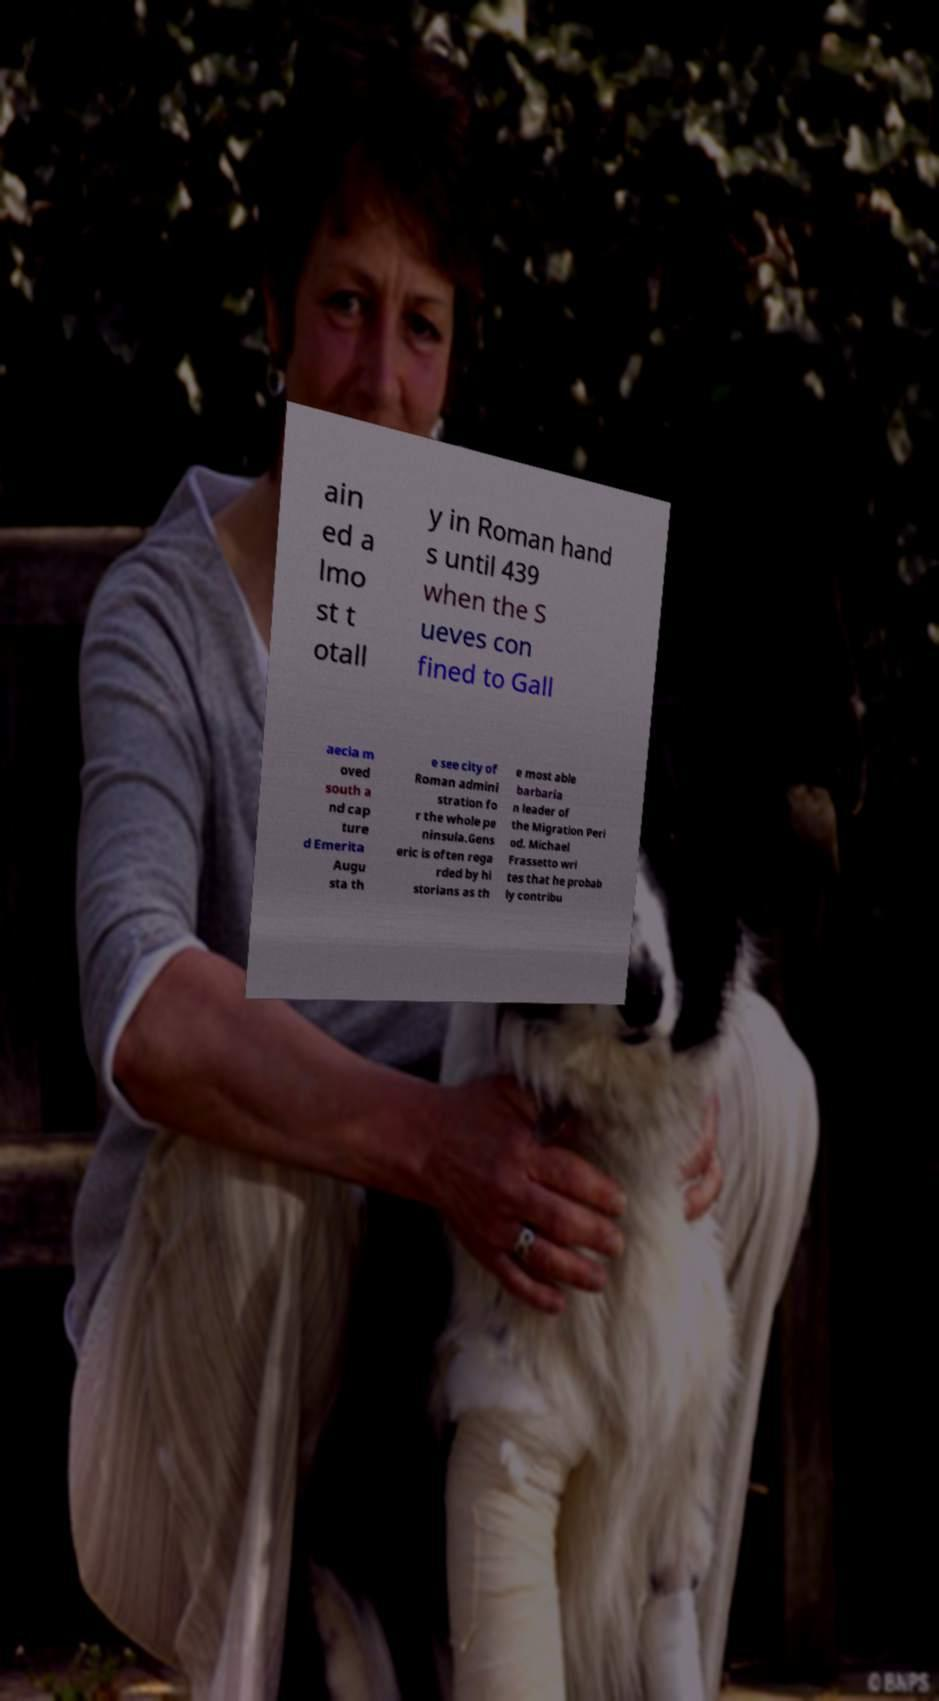What messages or text are displayed in this image? I need them in a readable, typed format. ain ed a lmo st t otall y in Roman hand s until 439 when the S ueves con fined to Gall aecia m oved south a nd cap ture d Emerita Augu sta th e see city of Roman admini stration fo r the whole pe ninsula.Gens eric is often rega rded by hi storians as th e most able barbaria n leader of the Migration Peri od. Michael Frassetto wri tes that he probab ly contribu 